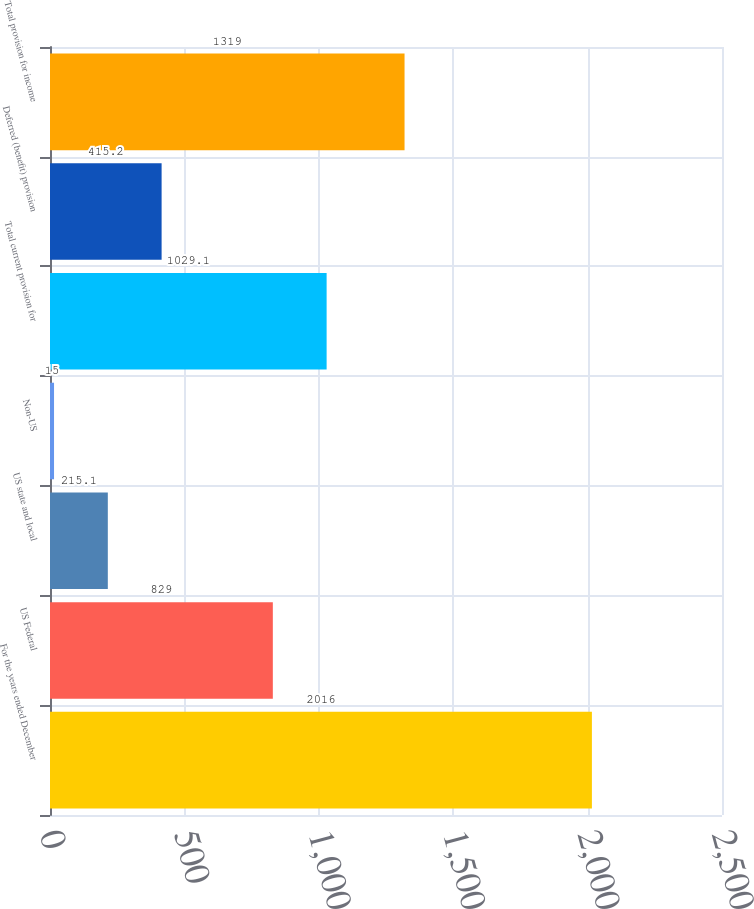<chart> <loc_0><loc_0><loc_500><loc_500><bar_chart><fcel>For the years ended December<fcel>US Federal<fcel>US state and local<fcel>Non-US<fcel>Total current provision for<fcel>Deferred (benefit) provision<fcel>Total provision for income<nl><fcel>2016<fcel>829<fcel>215.1<fcel>15<fcel>1029.1<fcel>415.2<fcel>1319<nl></chart> 